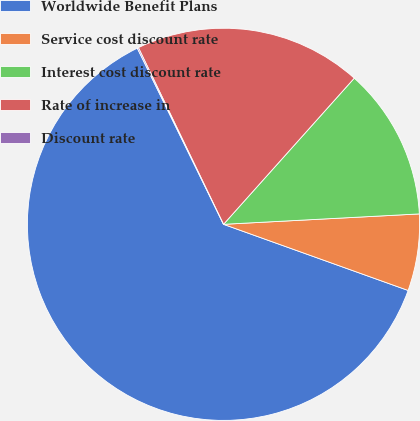Convert chart to OTSL. <chart><loc_0><loc_0><loc_500><loc_500><pie_chart><fcel>Worldwide Benefit Plans<fcel>Service cost discount rate<fcel>Interest cost discount rate<fcel>Rate of increase in<fcel>Discount rate<nl><fcel>62.28%<fcel>6.32%<fcel>12.54%<fcel>18.76%<fcel>0.1%<nl></chart> 